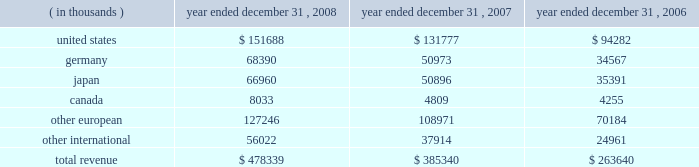15 .
Leases in january 1996 , the company entered into a lease agreement with an unrelated third party for a new corporate office facility , which the company occupied in february 1997 .
In may 2004 , the company entered into the first amendment to this lease agreement , effective january 1 , 2004 .
The lease was extended from an original period of 10 years , with an option for five additional years , to a period of 18 years from the inception date , with an option for five additional years .
The company incurred lease rental expense related to this facility of $ 1.3 million in 2008 , 2007 and 2006 .
The future minimum lease payments are $ 1.4 million per annum from january 1 , 2009 to december 31 , 2014 .
The future minimum lease payments from january 1 , 2015 through december 31 , 2019 will be determined based on prevailing market rental rates at the time of the extension , if elected .
The amended lease also provided for the lessor to reimburse the company for up to $ 550000 in building refurbishments completed through march 31 , 2006 .
These amounts have been recorded as a reduction of lease expense over the remaining term of the lease .
The company has also entered into various noncancellable operating leases for equipment and office space .
Office space lease expense totaled $ 9.3 million , $ 6.3 million and $ 4.7 million for the years ended december 31 , 2008 , 2007 and 2006 , respectively .
Future minimum lease payments under noncancellable operating leases for office space in effect at december 31 , 2008 are $ 8.8 million in 2009 , $ 6.6 million in 2010 , $ 3.0 million in 2011 , $ 1.8 million in 2012 and $ 1.1 million in 2013 .
16 .
Royalty agreements the company has entered into various renewable , nonexclusive license agreements under which the company has been granted access to the licensor 2019s technology and the right to sell the technology in the company 2019s product line .
Royalties are payable to developers of the software at various rates and amounts , which generally are based upon unit sales or revenue .
Royalty fees are reported in cost of goods sold and were $ 6.3 million , $ 5.2 million and $ 3.9 million for the years ended december 31 , 2008 , 2007 and 2006 , respectively .
17 .
Geographic information revenue to external customers is attributed to individual countries based upon the location of the customer .
Revenue by geographic area is as follows: .

What is the total combined royalty fees for years ended 2006-2008 , in millions? 
Computations: ((6.3 + 5.2) + 3.9)
Answer: 15.4. 